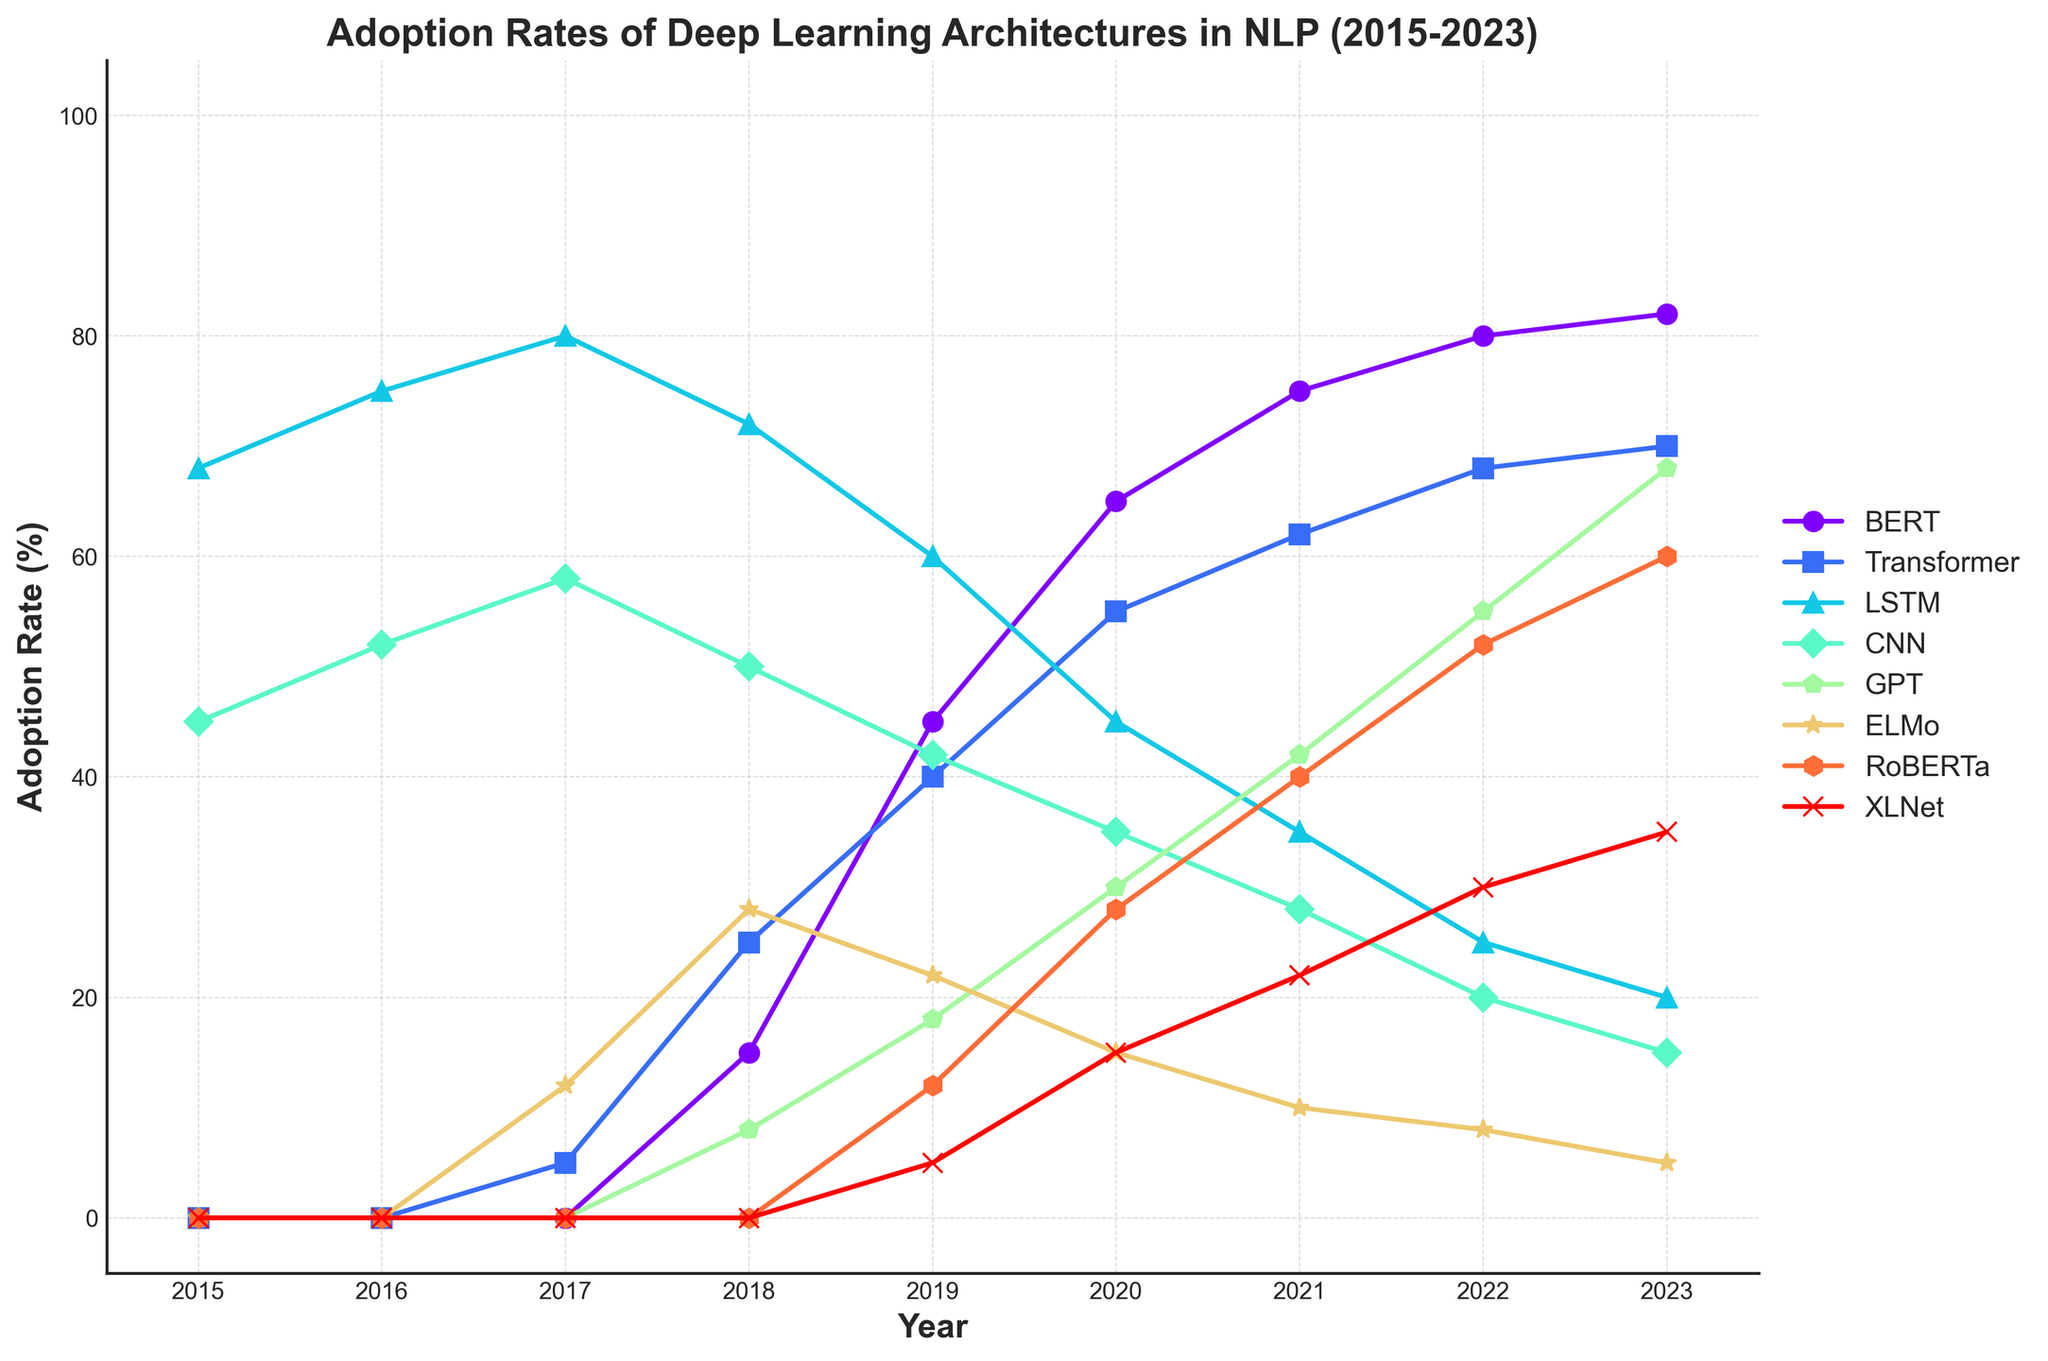Which architecture saw the highest adoption rate increase from 2017 to 2018? To find the highest adoption rate increase, calculate the difference for each architecture between 2017 and 2018, then compare these differences. Differences: BERT (15 - 0 = 15), Transformer (25 - 5 = 20), LSTM (72 - 80 = -8), CNN (50 - 58 = -8), GPT (8 - 0 = 8), ELMo (28 - 12 = 16), RoBERTa (0 - 0 = 0), XLNet (0 - 0 = 0). Transformer has the highest increase of 20.
Answer: Transformer In which year did GPT surpass the LSTM adoption rate? Look at the data points and compare the adoption rates of GPT and LSTM each year. GPT surpasses LSTM in 2023 (GPT 68%, LSTM 20%).
Answer: 2023 Between 2019 and 2022, which architecture had the most significant drop in adoption rate? Calculate the difference in adoption rates for each architecture between 2019 and 2022. Then, identify the largest drop. Differences: BERT (80 - 45 = 35), Transformer (68 - 40 = 28), LSTM (25 - 60 = -35), CNN (20 - 42 = -22), GPT (55 - 18 = 37), ELMo (8 - 22 = -14), RoBERTa (52 - 12 = 40), XLNet (30 - 5 = 25). LSTM has the largest drop of -35.
Answer: LSTM What's the difference in adoption rate between BERT and RoBERTa in 2023? Subtract the adoption rate of RoBERTa from BERT in 2023. Difference: 82% (BERT) - 60% (RoBERTa) = 22%.
Answer: 22% Which architectures were not adopted in 2016? Find the architectures with a 0% adoption rate in 2016. These are BERT, Transformer, GPT, ELMo, RoBERTa, and XLNet.
Answer: BERT, Transformer, GPT, ELMo, RoBERTa, XLNet In which year did BERT surpass an adoption rate of 50%? Identify the first year where BERT's adoption rate is greater than 50%. The data show that this happens in 2019 with a 45% rate increasing to 65% in 2020.
Answer: 2020 Which architecture had the highest adoption rate in 2015? Compare the adoption rates of all architectures in 2015. LSTM has the highest with 68%.
Answer: LSTM In 2021, what was the combined adoption rate of CNN and ELMo? Sum the adoption rates of CNN and ELMo in 2021. Combined rate: 28 (CNN) + 10 (ELMo) = 38%.
Answer: 38% Which architecture saw a consistent increase in adoption rate every year from 2018 to 2023? Check if any architecture's adoption rate increased consistently every year from 2018 to 2023. BERT's rates are 15, 45, 65, 75, 80, 82; hence it saw consistent increases.
Answer: BERT 